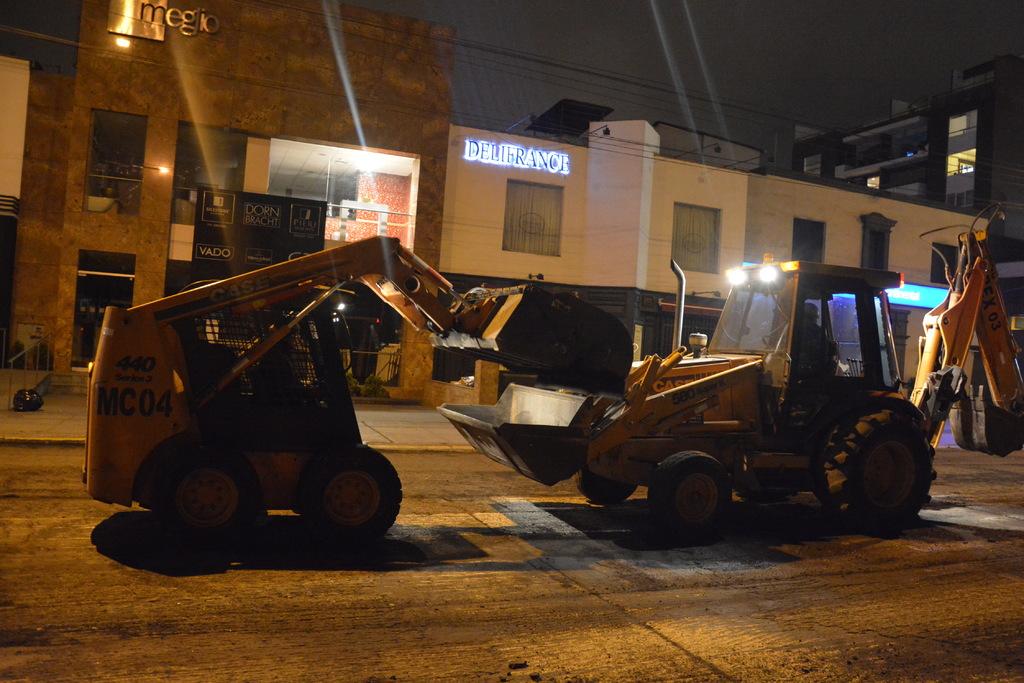What's the name of the white building?
Your response must be concise. Delifrance. What word is on the neck of the bulldozers?
Make the answer very short. Case. 